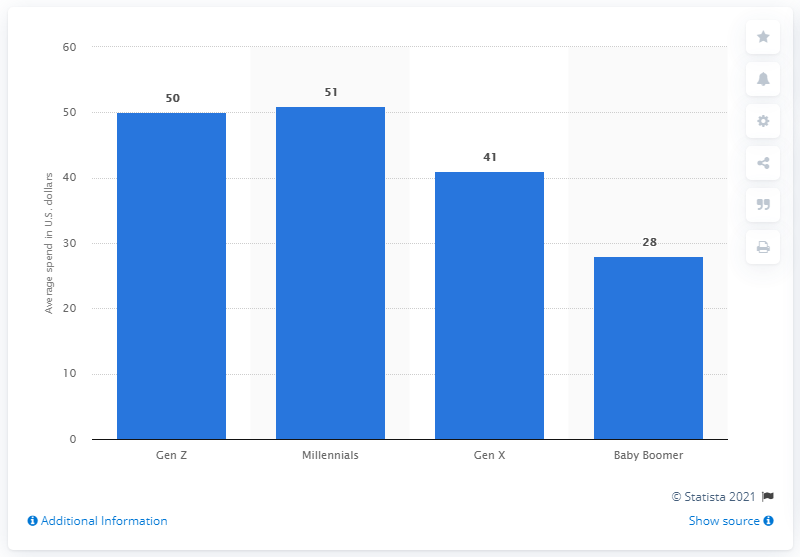What does this chart suggest about the spending habits of different generations? This chart suggests that there are generational differences in spending habits on pets during the holiday season, with Millennials and Gen Z spending more on average compared to Gen X and Baby Boomers. It might imply that younger generations place a higher financial value on pet care or that they tend to celebrate the holiday season with their pets in a more lavish way. 